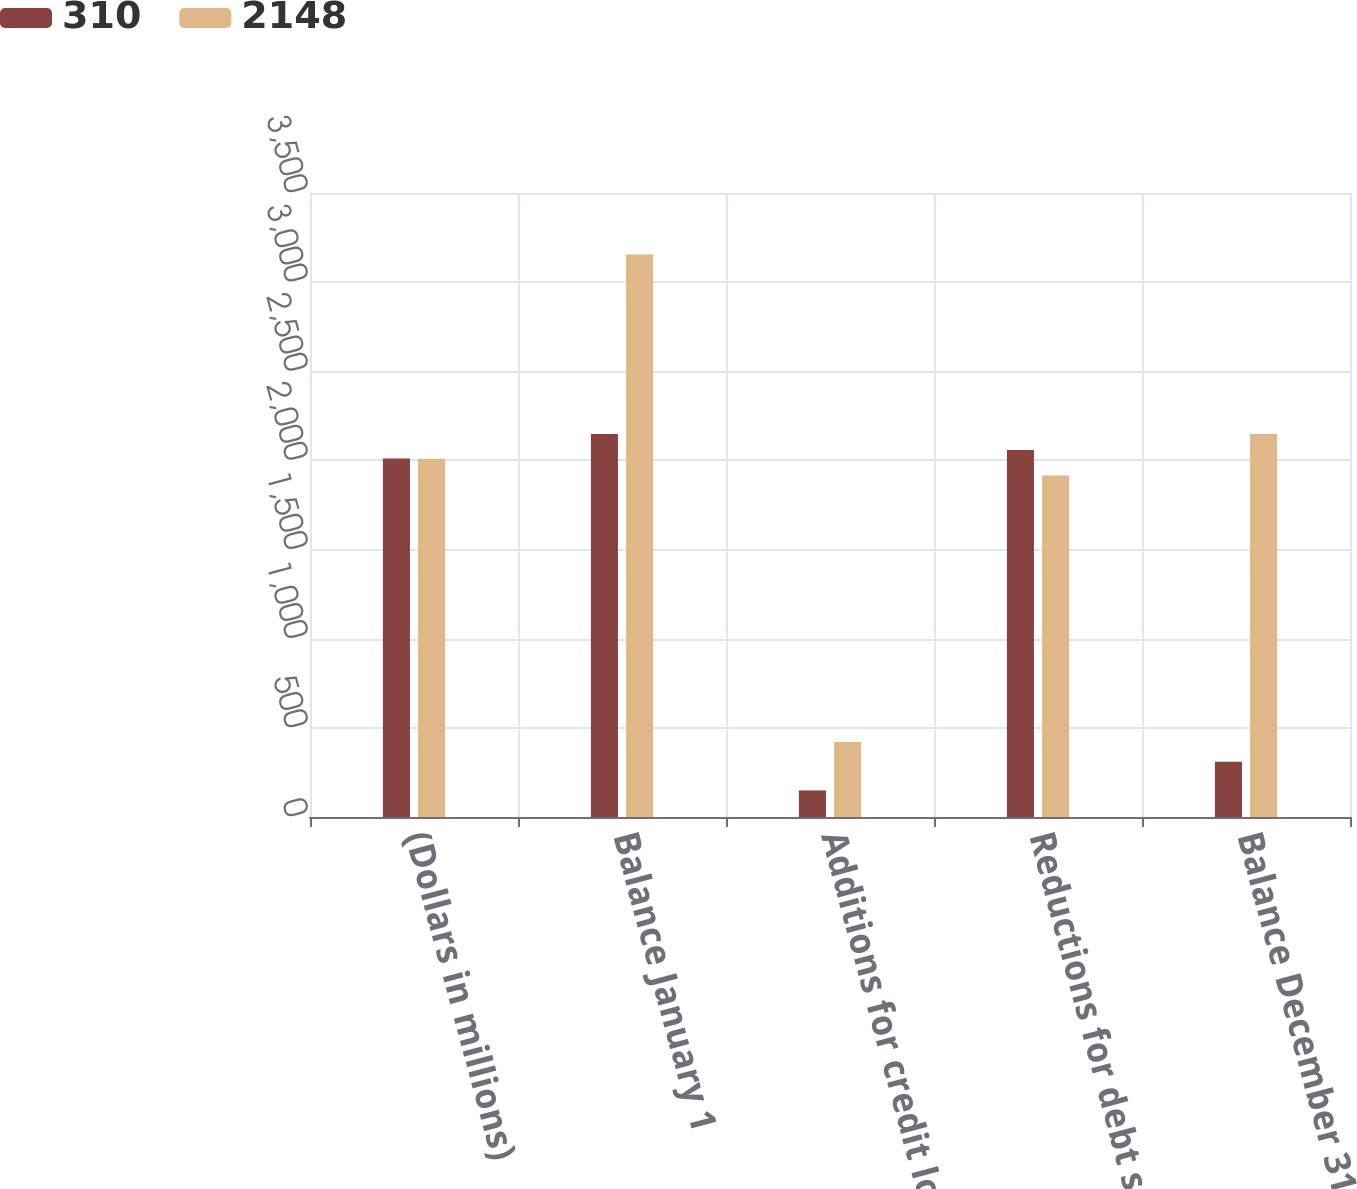Convert chart to OTSL. <chart><loc_0><loc_0><loc_500><loc_500><stacked_bar_chart><ecel><fcel>(Dollars in millions)<fcel>Balance January 1<fcel>Additions for credit losses<fcel>Reductions for debt securities<fcel>Balance December 31<nl><fcel>310<fcel>2011<fcel>2148<fcel>149<fcel>2059<fcel>310<nl><fcel>2148<fcel>2010<fcel>3155<fcel>421<fcel>1915<fcel>2148<nl></chart> 